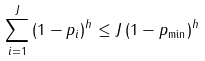<formula> <loc_0><loc_0><loc_500><loc_500>\sum _ { i = 1 } ^ { J } \left ( 1 - p _ { i } \right ) ^ { h } \leq J \left ( 1 - p _ { \min } \right ) ^ { h }</formula> 